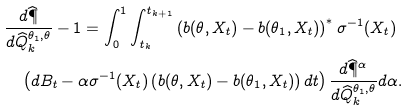<formula> <loc_0><loc_0><loc_500><loc_500>& \frac { d \widehat { \P } } { d \widehat { Q } _ { k } ^ { \theta _ { 1 } , \theta } } - 1 = \int _ { 0 } ^ { 1 } \int _ { t _ { k } } ^ { t _ { k + 1 } } \left ( b ( \theta , X _ { t } ) - b ( \theta _ { 1 } , X _ { t } ) \right ) ^ { \ast } \sigma ^ { - 1 } ( X _ { t } ) \\ & \quad \left ( d B _ { t } - \alpha \sigma ^ { - 1 } ( X _ { t } ) \left ( b ( \theta , X _ { t } ) - b ( \theta _ { 1 } , X _ { t } ) \right ) d t \right ) \frac { d \widehat { \P } ^ { \alpha } } { d \widehat { Q } _ { k } ^ { \theta _ { 1 } , \theta } } d \alpha .</formula> 